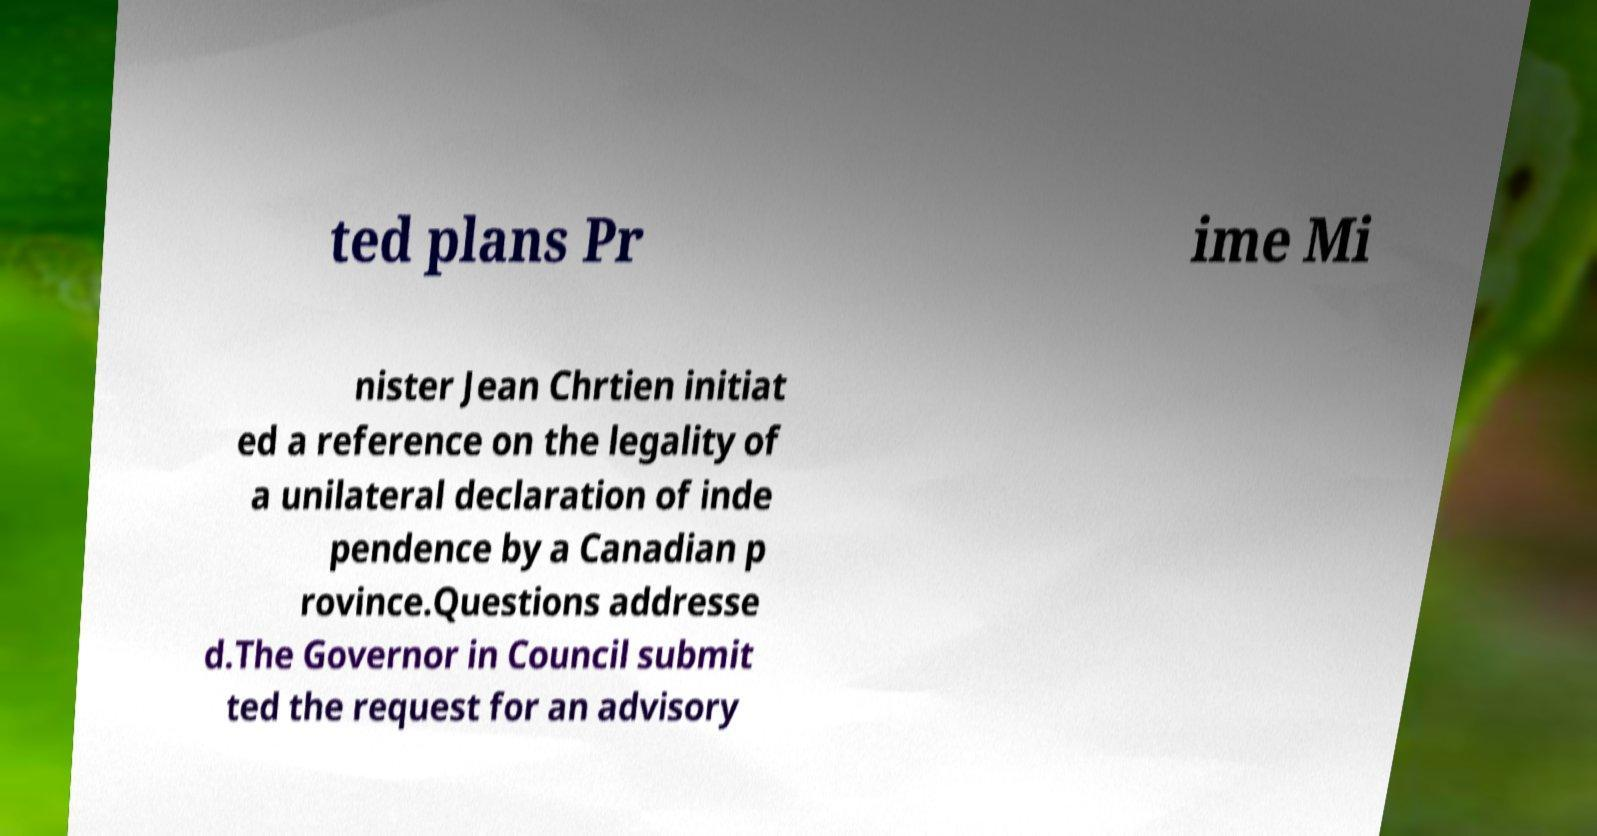Could you assist in decoding the text presented in this image and type it out clearly? ted plans Pr ime Mi nister Jean Chrtien initiat ed a reference on the legality of a unilateral declaration of inde pendence by a Canadian p rovince.Questions addresse d.The Governor in Council submit ted the request for an advisory 